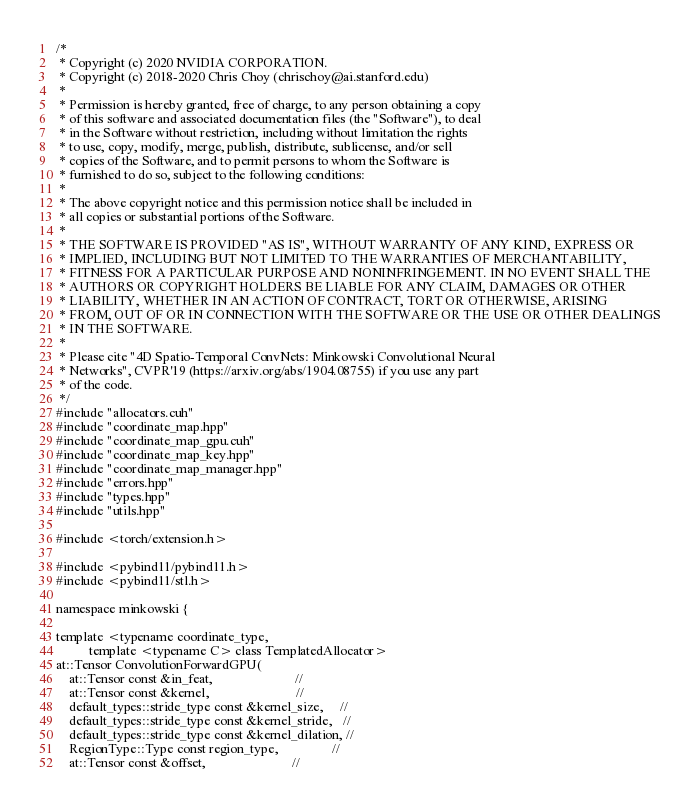<code> <loc_0><loc_0><loc_500><loc_500><_Cuda_>/*
 * Copyright (c) 2020 NVIDIA CORPORATION.
 * Copyright (c) 2018-2020 Chris Choy (chrischoy@ai.stanford.edu)
 *
 * Permission is hereby granted, free of charge, to any person obtaining a copy
 * of this software and associated documentation files (the "Software"), to deal
 * in the Software without restriction, including without limitation the rights
 * to use, copy, modify, merge, publish, distribute, sublicense, and/or sell
 * copies of the Software, and to permit persons to whom the Software is
 * furnished to do so, subject to the following conditions:
 *
 * The above copyright notice and this permission notice shall be included in
 * all copies or substantial portions of the Software.
 *
 * THE SOFTWARE IS PROVIDED "AS IS", WITHOUT WARRANTY OF ANY KIND, EXPRESS OR
 * IMPLIED, INCLUDING BUT NOT LIMITED TO THE WARRANTIES OF MERCHANTABILITY,
 * FITNESS FOR A PARTICULAR PURPOSE AND NONINFRINGEMENT. IN NO EVENT SHALL THE
 * AUTHORS OR COPYRIGHT HOLDERS BE LIABLE FOR ANY CLAIM, DAMAGES OR OTHER
 * LIABILITY, WHETHER IN AN ACTION OF CONTRACT, TORT OR OTHERWISE, ARISING
 * FROM, OUT OF OR IN CONNECTION WITH THE SOFTWARE OR THE USE OR OTHER DEALINGS
 * IN THE SOFTWARE.
 *
 * Please cite "4D Spatio-Temporal ConvNets: Minkowski Convolutional Neural
 * Networks", CVPR'19 (https://arxiv.org/abs/1904.08755) if you use any part
 * of the code.
 */
#include "allocators.cuh"
#include "coordinate_map.hpp"
#include "coordinate_map_gpu.cuh"
#include "coordinate_map_key.hpp"
#include "coordinate_map_manager.hpp"
#include "errors.hpp"
#include "types.hpp"
#include "utils.hpp"

#include <torch/extension.h>

#include <pybind11/pybind11.h>
#include <pybind11/stl.h>

namespace minkowski {

template <typename coordinate_type,
          template <typename C> class TemplatedAllocator>
at::Tensor ConvolutionForwardGPU(
    at::Tensor const &in_feat,                         //
    at::Tensor const &kernel,                          //
    default_types::stride_type const &kernel_size,     //
    default_types::stride_type const &kernel_stride,   //
    default_types::stride_type const &kernel_dilation, //
    RegionType::Type const region_type,                //
    at::Tensor const &offset,                          //</code> 